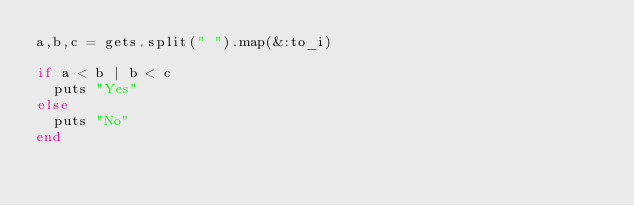Convert code to text. <code><loc_0><loc_0><loc_500><loc_500><_Ruby_>a,b,c = gets.split(" ").map(&:to_i)

if a < b | b < c
  puts "Yes"
else
  puts "No"
end</code> 